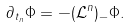<formula> <loc_0><loc_0><loc_500><loc_500>\partial _ { t _ { n } } \Phi = - ( \mathcal { L } ^ { n } ) _ { - } \Phi .</formula> 